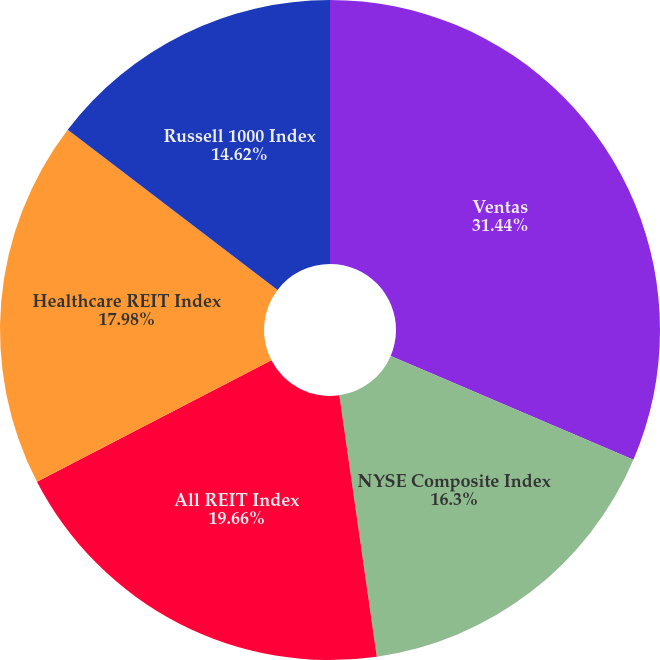<chart> <loc_0><loc_0><loc_500><loc_500><pie_chart><fcel>Ventas<fcel>NYSE Composite Index<fcel>All REIT Index<fcel>Healthcare REIT Index<fcel>Russell 1000 Index<nl><fcel>31.43%<fcel>16.3%<fcel>19.66%<fcel>17.98%<fcel>14.62%<nl></chart> 